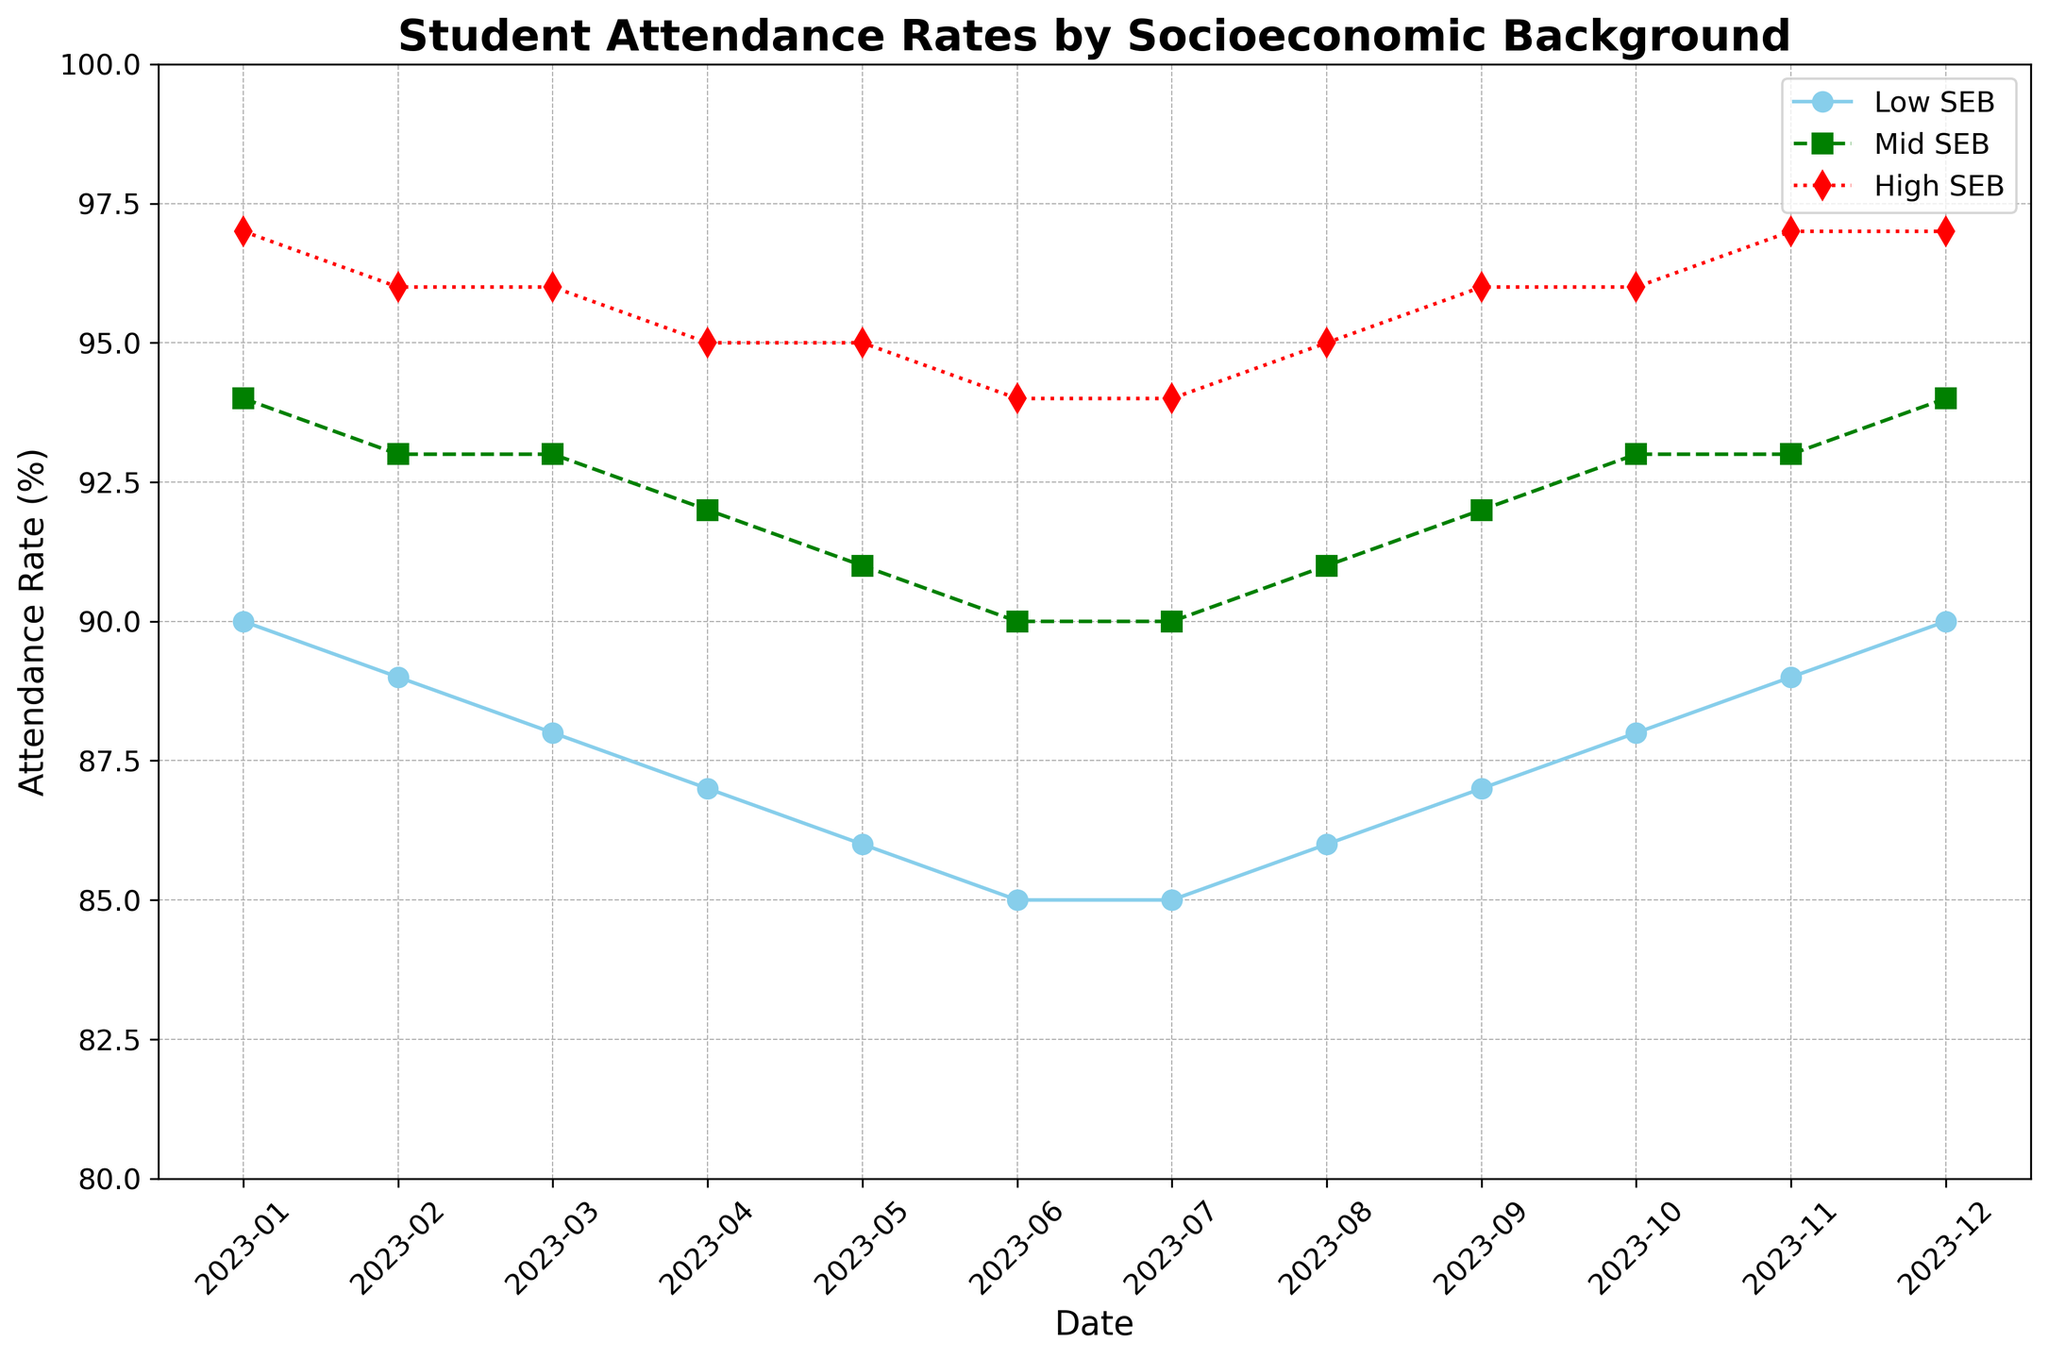What is the general trend in attendance rates for Low_SEB students over the year? To find the general trend, we observe the line for Low_SEB students from January to December. The line generally decreases from 90% in January to 85% in June and July, before increasing again to 90% by December.
Answer: Decreasing then increasing Which month has the highest attendance rate for High_SEB students? To determine the highest attendance rate, examine the red line representing High_SEB students. It peaks at 97% in January, November, and December.
Answer: January, November, December By how many percentage points did the attendance rate for Low_SEB students change from January to July? In January, Low_SEB students had an attendance rate of 90%. By July, this rate was 85%. Therefore, the change is 90% - 85% = 5 percentage points.
Answer: 5 percentage points What was the attendance rate for Mid_SEB students in June? Look at where the green line for Mid_SEB students intersects with June on the x-axis. The attendance rate is 90%.
Answer: 90% How do the attendance rates of Low_SEB and High_SEB students compare in May? Compare the attendance rates for May by looking at where the 'Low_SEB' and 'High_SEB' lines intersect with May on the x-axis. Low_SEB is at 86%, and High_SEB is at 95%, so High_SEB has a higher rate.
Answer: High_SEB is higher What is the average attendance rate for Mid_SEB students across the entire year? Calculate the average by summing up the attendance rates for Mid_SEB students (94+93+93+92+91+90+90+91+92+93+93+94) and dividing by 12. The sum is 1106, and the average is 1106/12 = 92.17%.
Answer: 92.17% During which month(s) do Low_SEB and Mid_SEB students have the same attendance rate? Compare the values for Low_SEB and Mid_SEB across each month. In July, both Low_SEB and Mid_SEB students have an attendance rate of 90%.
Answer: July What is the difference in attendance rates between High_SEB and Low_SEB students in September? To find the difference, subtract the attendance rate of Low_SEB from that of High_SEB in September. It's 96% (High_SEB) - 87% (Low_SEB) = 9%.
Answer: 9% Which socioeconomic group shows the least change in attendance rates over the year? To determine the group with the least change, observe the range of attendance rates for each group. High_SEB ranges from 94% to 97% (a change of 3 percentage points), Mid_SEB from 90% to 94% (4 percentage points), and Low_SEB from 85% to 90% (5 percentage points). Therefore, High_SEB has the least change.
Answer: High_SEB In which month did all three groups have the closest attendance rates? Examine the data month by month to find the month with the smallest range in attendance rates among the three groups. In July, Low_SEB is at 85%, Mid_SEB is at 90%, and High_SEB is at 94%, resulting in the closest range.
Answer: July 